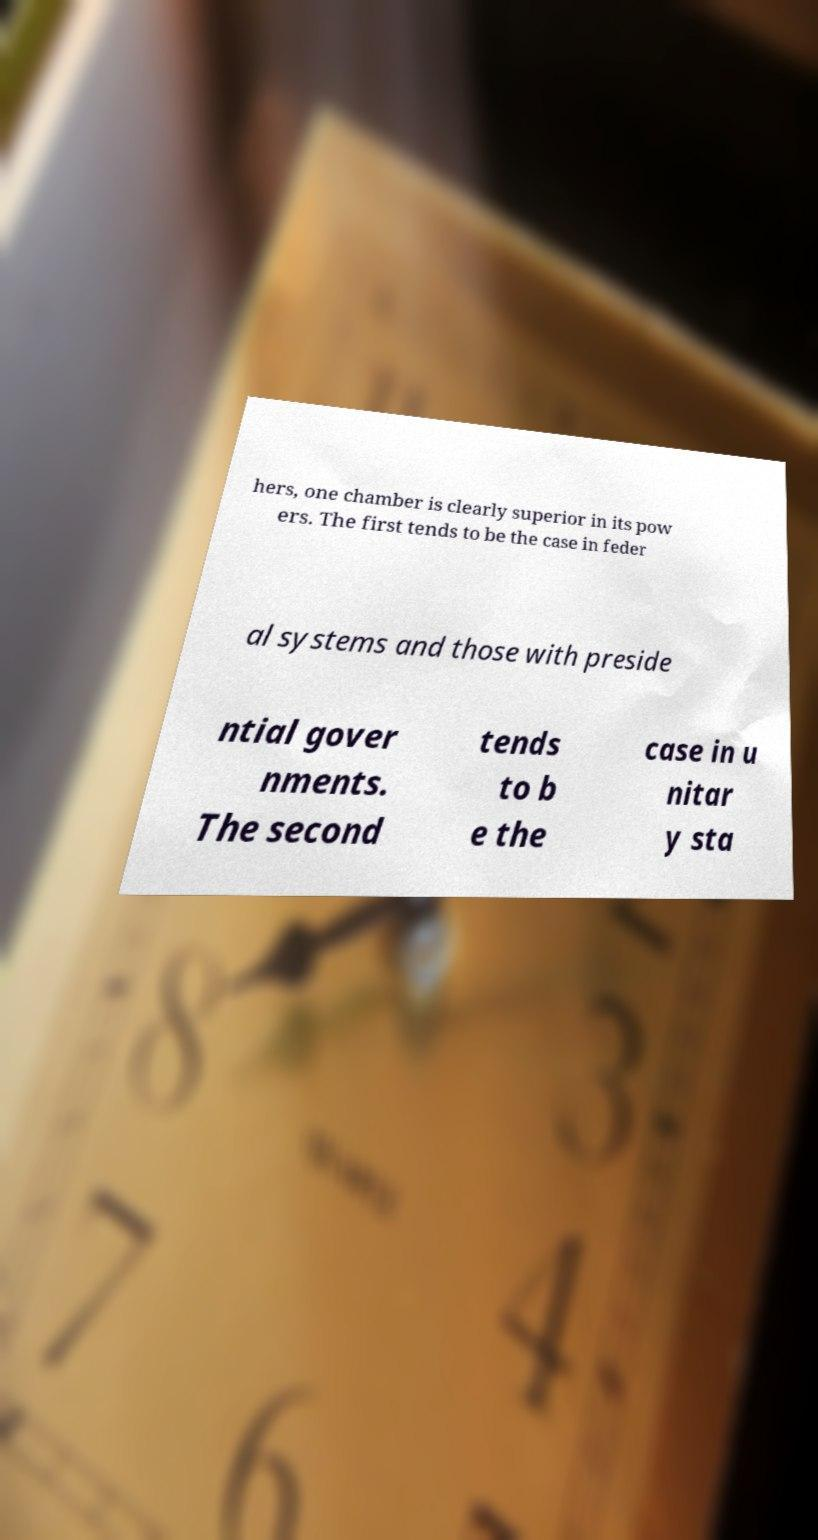Please identify and transcribe the text found in this image. hers, one chamber is clearly superior in its pow ers. The first tends to be the case in feder al systems and those with preside ntial gover nments. The second tends to b e the case in u nitar y sta 